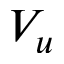Convert formula to latex. <formula><loc_0><loc_0><loc_500><loc_500>V _ { u }</formula> 